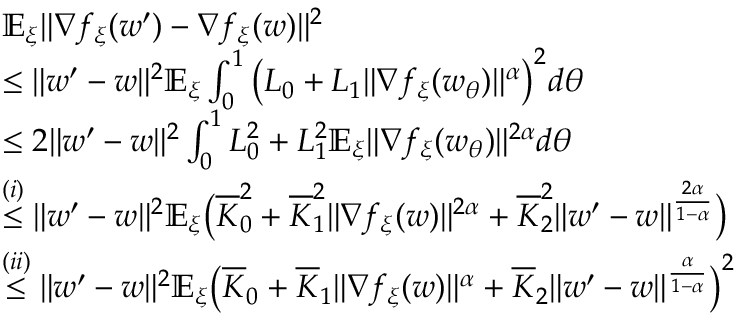Convert formula to latex. <formula><loc_0><loc_0><loc_500><loc_500>\begin{array} { r l } & { \mathbb { E } _ { \xi } \| \nabla f _ { \xi } ( w ^ { \prime } ) - \nabla f _ { \xi } ( w ) \| ^ { 2 } } \\ & { \leq \| w ^ { \prime } - w \| ^ { 2 } \mathbb { E } _ { \xi } \int _ { 0 } ^ { 1 } \left ( L _ { 0 } + L _ { 1 } \| \nabla f _ { \xi } ( w _ { \theta } ) \| ^ { \alpha } \right ) ^ { 2 } d \theta } \\ & { \leq 2 \| w ^ { \prime } - w \| ^ { 2 } \int _ { 0 } ^ { 1 } L _ { 0 } ^ { 2 } + L _ { 1 } ^ { 2 } \mathbb { E } _ { \xi } \| \nabla f _ { \xi } ( w _ { \theta } ) \| ^ { 2 \alpha } d \theta } \\ & { \overset { ( i ) } { \leq } \| w ^ { \prime } - w \| ^ { 2 } \mathbb { E } _ { \xi } \left ( \overline { K } _ { 0 } ^ { 2 } + \overline { K } _ { 1 } ^ { 2 } \| \nabla f _ { \xi } ( w ) \| ^ { 2 \alpha } + \overline { K } _ { 2 } ^ { 2 } \| w ^ { \prime } - w \| ^ { \frac { 2 \alpha } { 1 - \alpha } } \right ) } \\ & { \overset { ( i i ) } { \leq } \| w ^ { \prime } - w \| ^ { 2 } \mathbb { E } _ { \xi } \left ( \overline { K } _ { 0 } + \overline { K } _ { 1 } \| \nabla f _ { \xi } ( w ) \| ^ { \alpha } + \overline { K } _ { 2 } \| w ^ { \prime } - w \| ^ { \frac { \alpha } { 1 - \alpha } } \right ) ^ { 2 } } \end{array}</formula> 